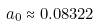<formula> <loc_0><loc_0><loc_500><loc_500>a _ { 0 } \approx 0 . 0 8 3 2 2</formula> 